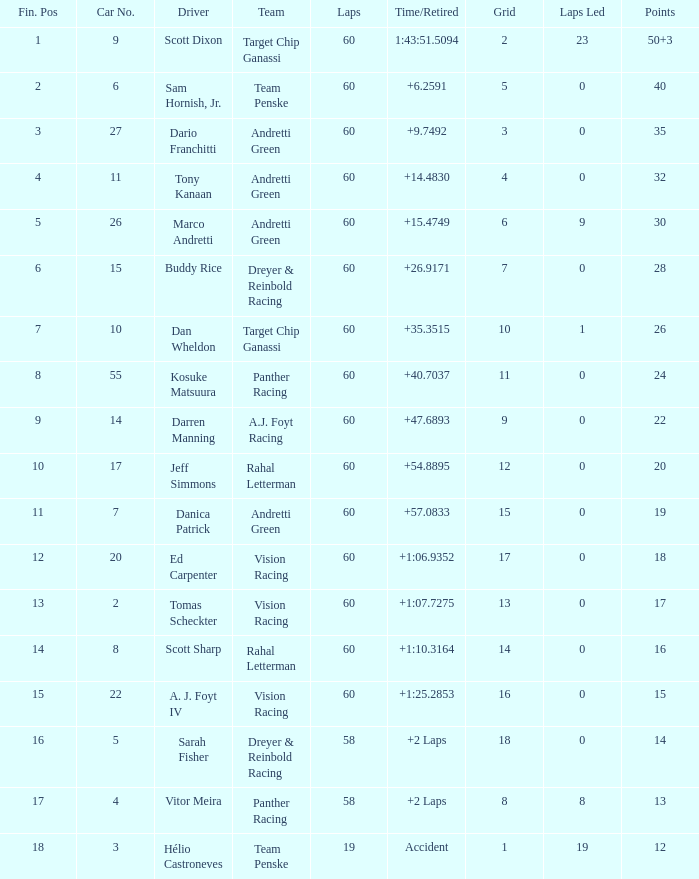Name the laps for 18 pointss 60.0. 